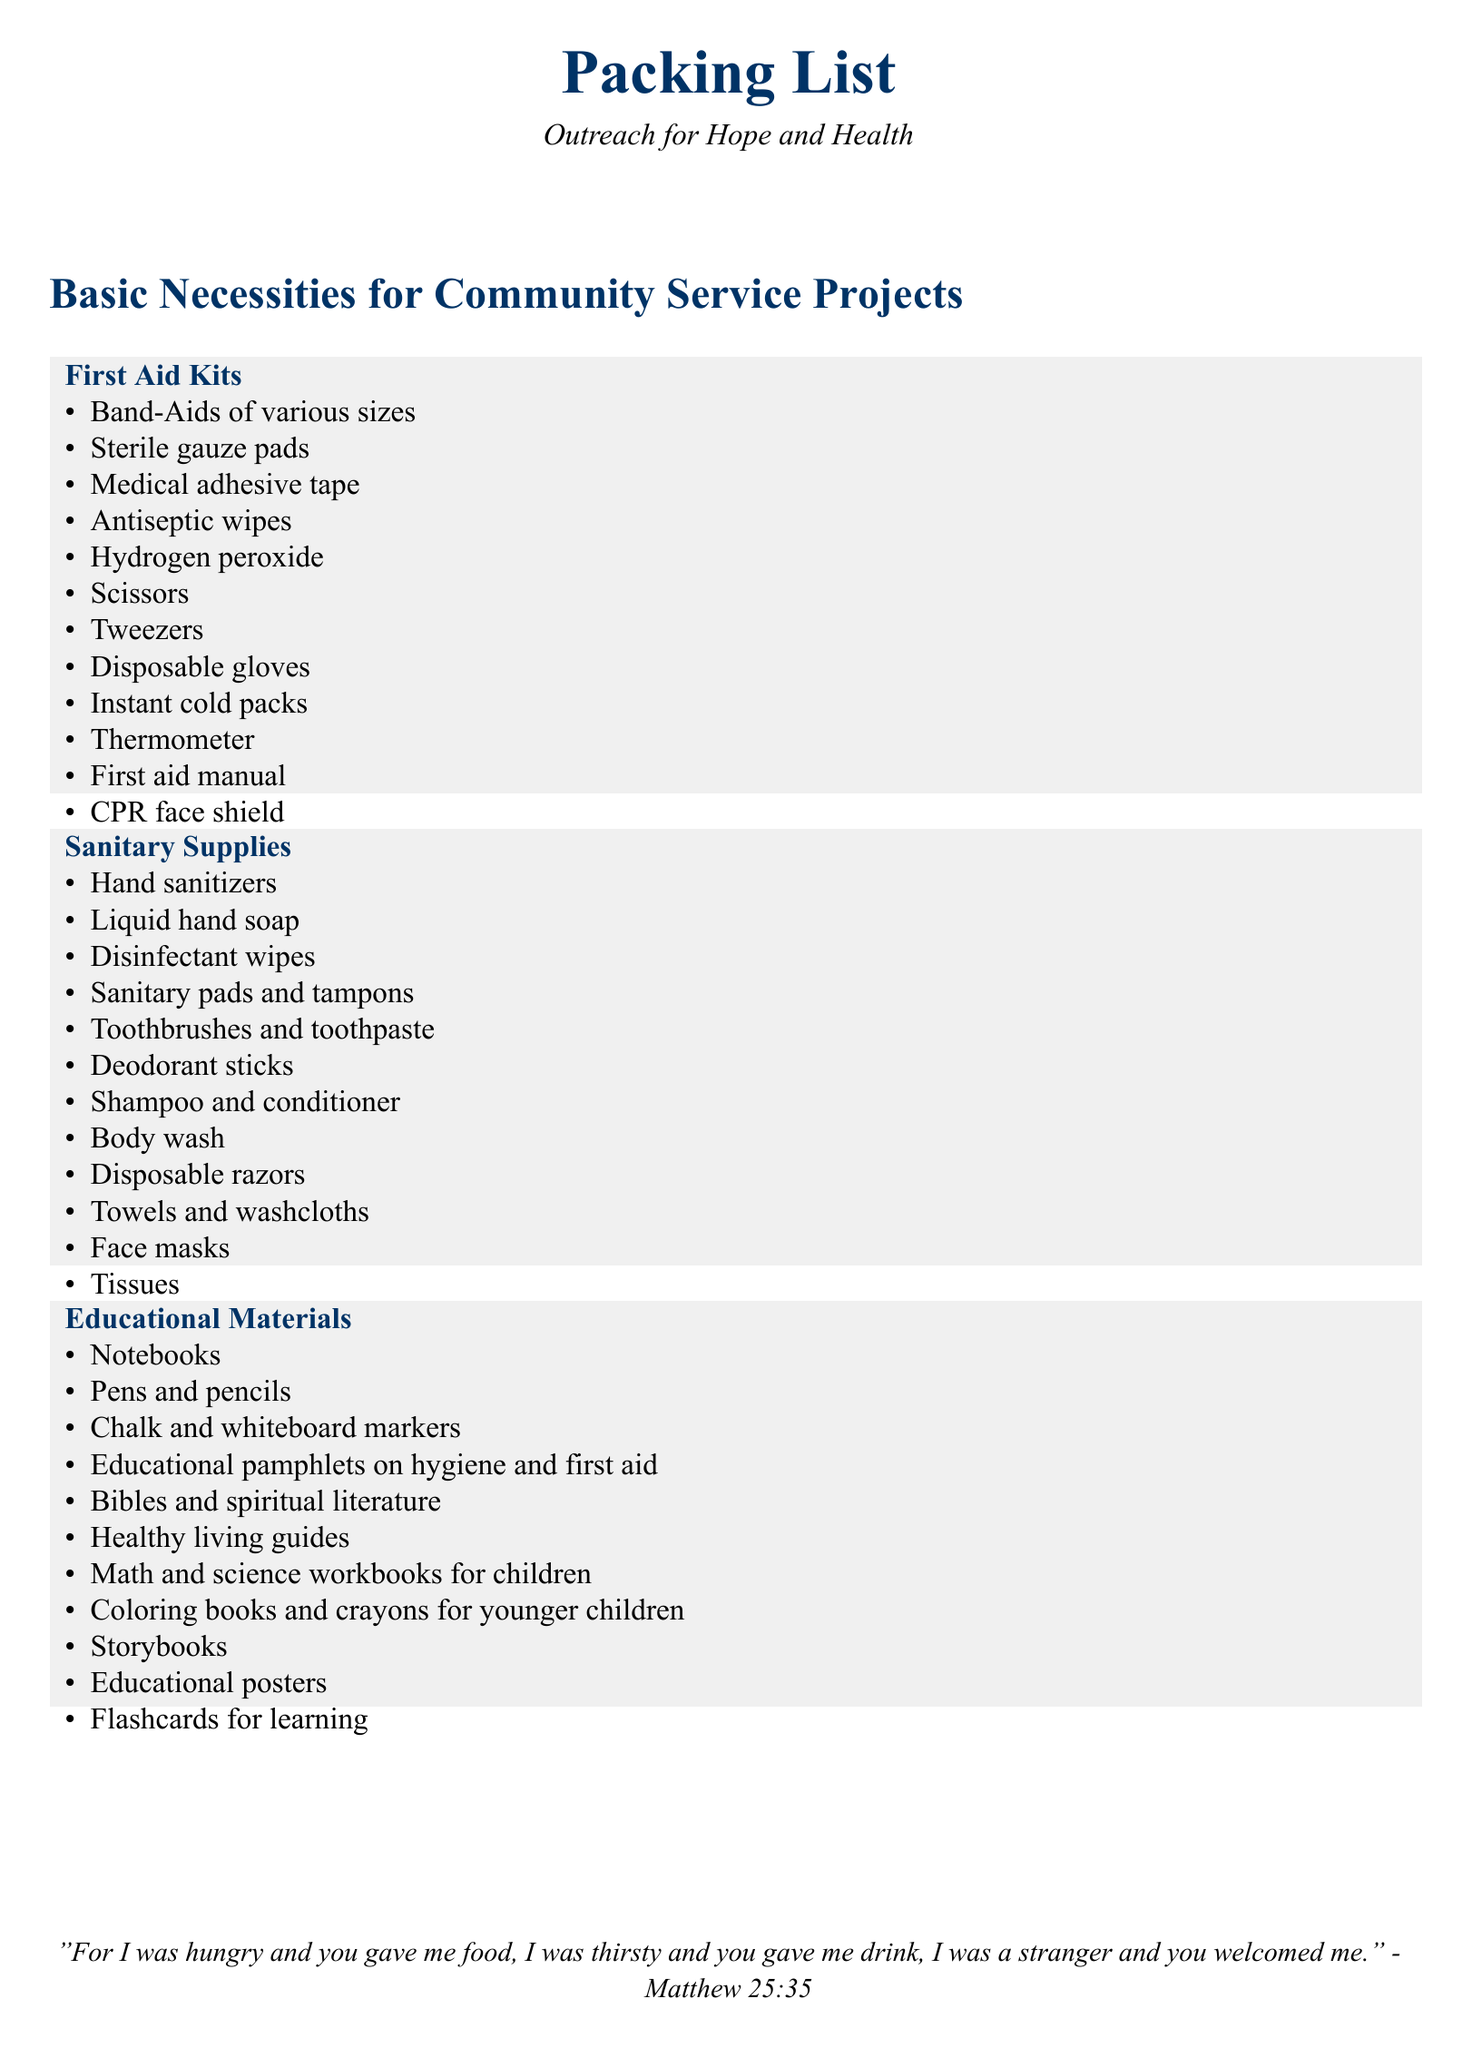What items are included in the first aid kit? The first aid kit includes a variety of items designed for medical emergencies, listed in the document.
Answer: Band-Aids of various sizes How many items are in the sanitary supplies section? The sanitary supplies section lists multiple essential items, as specified in the document.
Answer: 12 What kind of educational materials are listed? The document outlines various educational resources needed for outreach, detailing both the content and types of materials.
Answer: Notebooks Which item can be found in both the educational materials and the first aid kits? The document specifies common themes in the educational and first aid supplies, requiring comparison to answer this.
Answer: None What is the color theme used in the document? The document employs a specific color scheme for its title and sections, relevant for visual identification.
Answer: Jesuit blue How many first aid items are listed? A precise count of the items in the first aid kit is provided in the document, indicating its comprehensiveness.
Answer: 12 What type of literature is included in the educational materials? The educational materials section outlines various forms of literature to enhance learning and spiritual growth.
Answer: Bibles and spiritual literature What should you bring for maintaining personal hygiene? The document emphasizes personal cleanliness and provides a list of items required for sanitation during community service projects.
Answer: Hand sanitizers 